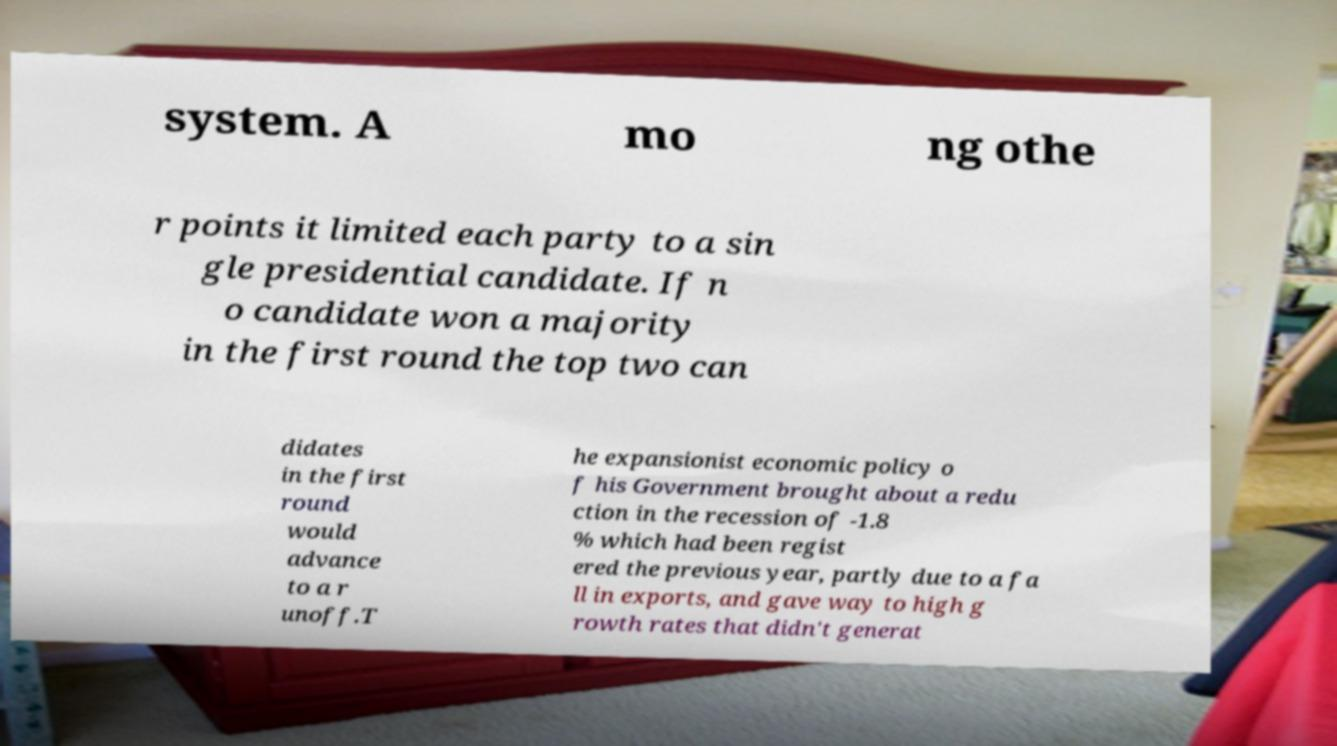Please read and relay the text visible in this image. What does it say? system. A mo ng othe r points it limited each party to a sin gle presidential candidate. If n o candidate won a majority in the first round the top two can didates in the first round would advance to a r unoff.T he expansionist economic policy o f his Government brought about a redu ction in the recession of -1.8 % which had been regist ered the previous year, partly due to a fa ll in exports, and gave way to high g rowth rates that didn't generat 